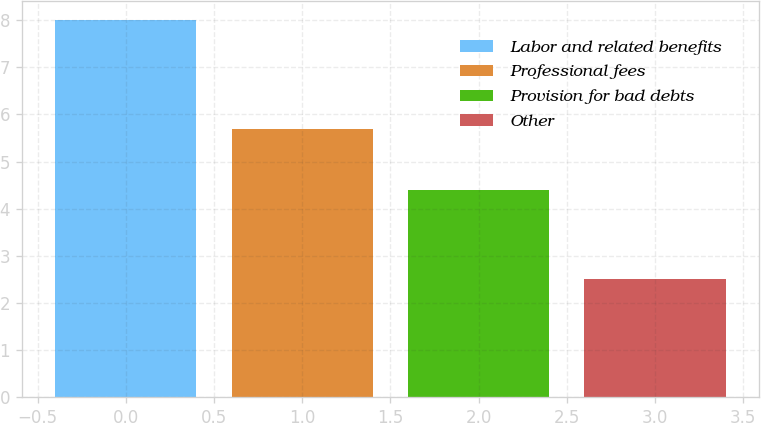Convert chart. <chart><loc_0><loc_0><loc_500><loc_500><bar_chart><fcel>Labor and related benefits<fcel>Professional fees<fcel>Provision for bad debts<fcel>Other<nl><fcel>8<fcel>5.7<fcel>4.4<fcel>2.5<nl></chart> 